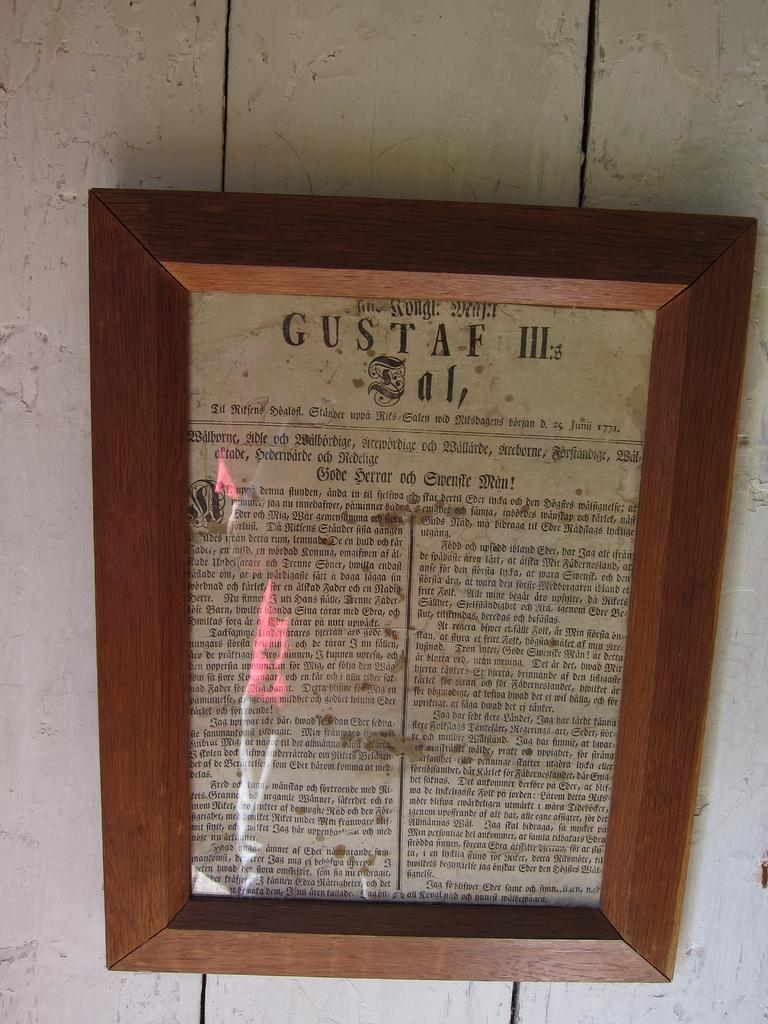Provide a one-sentence caption for the provided image. A very old newspaper called Gustaf III in a wooden frame. 